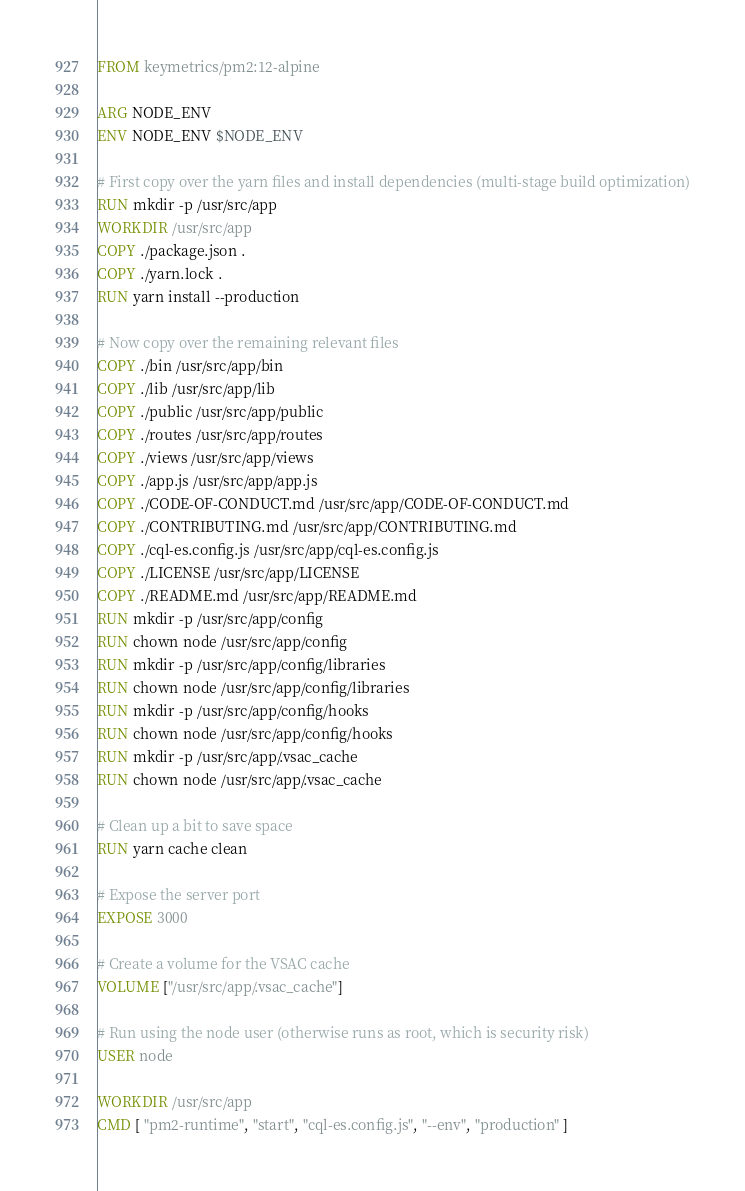<code> <loc_0><loc_0><loc_500><loc_500><_Dockerfile_>FROM keymetrics/pm2:12-alpine

ARG NODE_ENV
ENV NODE_ENV $NODE_ENV

# First copy over the yarn files and install dependencies (multi-stage build optimization)
RUN mkdir -p /usr/src/app
WORKDIR /usr/src/app
COPY ./package.json .
COPY ./yarn.lock .
RUN yarn install --production

# Now copy over the remaining relevant files
COPY ./bin /usr/src/app/bin
COPY ./lib /usr/src/app/lib
COPY ./public /usr/src/app/public
COPY ./routes /usr/src/app/routes
COPY ./views /usr/src/app/views
COPY ./app.js /usr/src/app/app.js
COPY ./CODE-OF-CONDUCT.md /usr/src/app/CODE-OF-CONDUCT.md
COPY ./CONTRIBUTING.md /usr/src/app/CONTRIBUTING.md
COPY ./cql-es.config.js /usr/src/app/cql-es.config.js
COPY ./LICENSE /usr/src/app/LICENSE
COPY ./README.md /usr/src/app/README.md
RUN mkdir -p /usr/src/app/config
RUN chown node /usr/src/app/config
RUN mkdir -p /usr/src/app/config/libraries
RUN chown node /usr/src/app/config/libraries
RUN mkdir -p /usr/src/app/config/hooks
RUN chown node /usr/src/app/config/hooks
RUN mkdir -p /usr/src/app/.vsac_cache
RUN chown node /usr/src/app/.vsac_cache

# Clean up a bit to save space
RUN yarn cache clean

# Expose the server port
EXPOSE 3000

# Create a volume for the VSAC cache
VOLUME ["/usr/src/app/.vsac_cache"]

# Run using the node user (otherwise runs as root, which is security risk)
USER node

WORKDIR /usr/src/app
CMD [ "pm2-runtime", "start", "cql-es.config.js", "--env", "production" ]</code> 